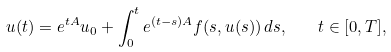<formula> <loc_0><loc_0><loc_500><loc_500>u ( t ) = e ^ { t A } u _ { 0 } + \int _ { 0 } ^ { t } e ^ { ( t - s ) A } f ( s , u ( s ) ) \, d s , \quad t \in [ 0 , T ] ,</formula> 